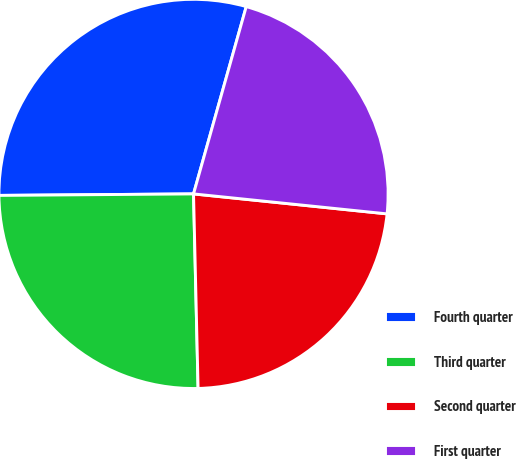Convert chart to OTSL. <chart><loc_0><loc_0><loc_500><loc_500><pie_chart><fcel>Fourth quarter<fcel>Third quarter<fcel>Second quarter<fcel>First quarter<nl><fcel>29.49%<fcel>25.25%<fcel>22.99%<fcel>22.27%<nl></chart> 